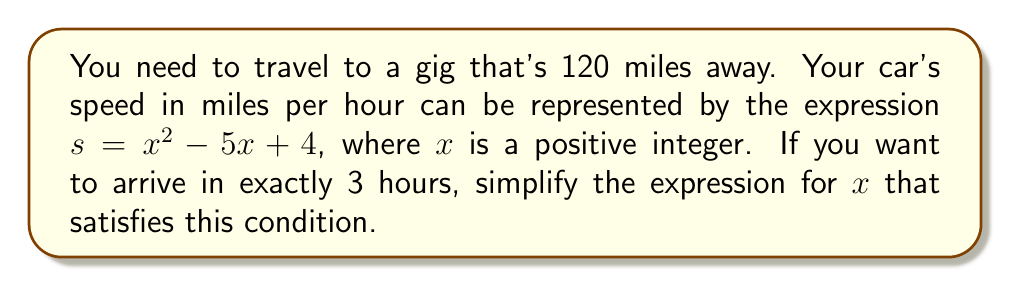Help me with this question. Let's approach this step-by-step:

1) First, we need to recall the formula for travel time:
   Time = Distance / Speed

2) We're given that the time is 3 hours and the distance is 120 miles. Let's substitute these into the formula:
   $3 = 120 / s$

3) Now, let's substitute the expression for speed:
   $3 = 120 / (x^2 - 5x + 4)$

4) To simplify this, let's multiply both sides by $(x^2 - 5x + 4)$:
   $3(x^2 - 5x + 4) = 120$

5) Let's expand the left side:
   $3x^2 - 15x + 12 = 120$

6) Subtract 120 from both sides:
   $3x^2 - 15x - 108 = 0$

7) To simplify this further, let's factor out the greatest common factor:
   $3(x^2 - 5x - 36) = 0$

8) Now, let's factor the quadratic expression inside the parentheses:
   $3(x - 9)(x + 4) = 0$

This is the simplified expression for $x$ that satisfies the condition. The solutions would be $x = 9$ or $x = -4$, but since we're told $x$ is a positive integer, only $x = 9$ is valid in this context.
Answer: $3(x - 9)(x + 4) = 0$ 